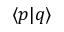<formula> <loc_0><loc_0><loc_500><loc_500>\langle p | q \rangle</formula> 